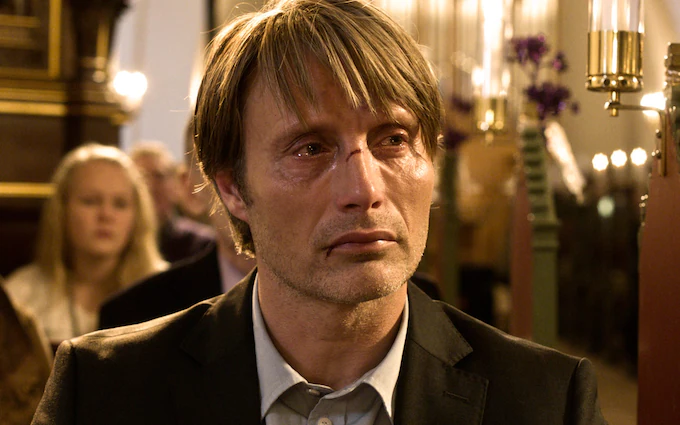Explain the visual content of the image in great detail. The image portrays a middle-aged man with long, tousled hair and a deep, contemplative expression. He is dressed in a formal black suit, which contrasts with the warm, golden hues of the church interior visible in the blurred background. His eyes, full of emotion, hint at a scene charged with introspection or sorrow. Behind him, soft focus reveals the outlines of other attendees and the ornate fixtures of the church, suggesting a solemn or significant event, possibly a service or a funeral. The overall composition and the man's expression elicit a sense of quiet introspection and the gravity of the moment. 